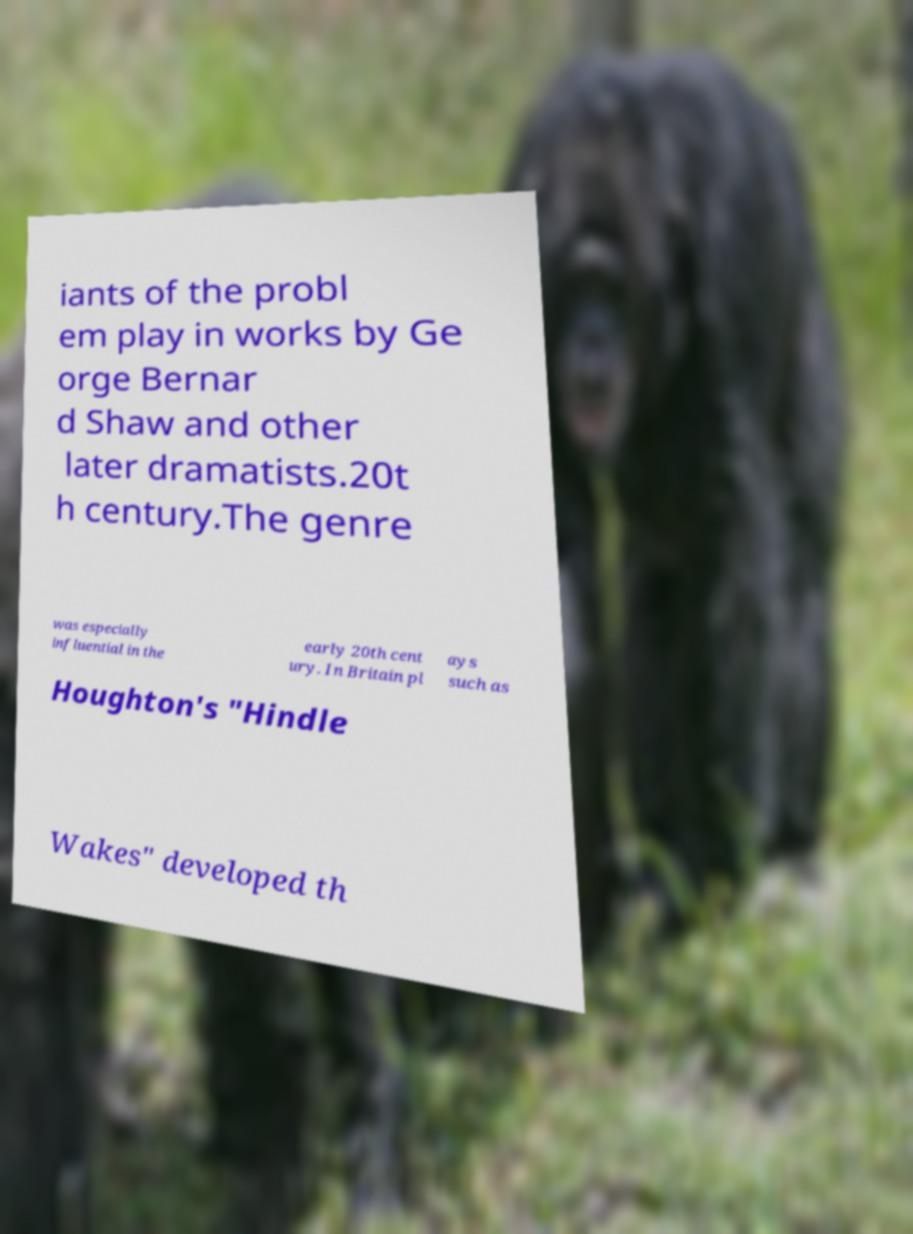For documentation purposes, I need the text within this image transcribed. Could you provide that? iants of the probl em play in works by Ge orge Bernar d Shaw and other later dramatists.20t h century.The genre was especially influential in the early 20th cent ury. In Britain pl ays such as Houghton's "Hindle Wakes" developed th 